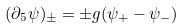<formula> <loc_0><loc_0><loc_500><loc_500>( \partial _ { 5 } \psi ) _ { \pm } = \pm g ( \psi _ { + } - \psi _ { - } )</formula> 